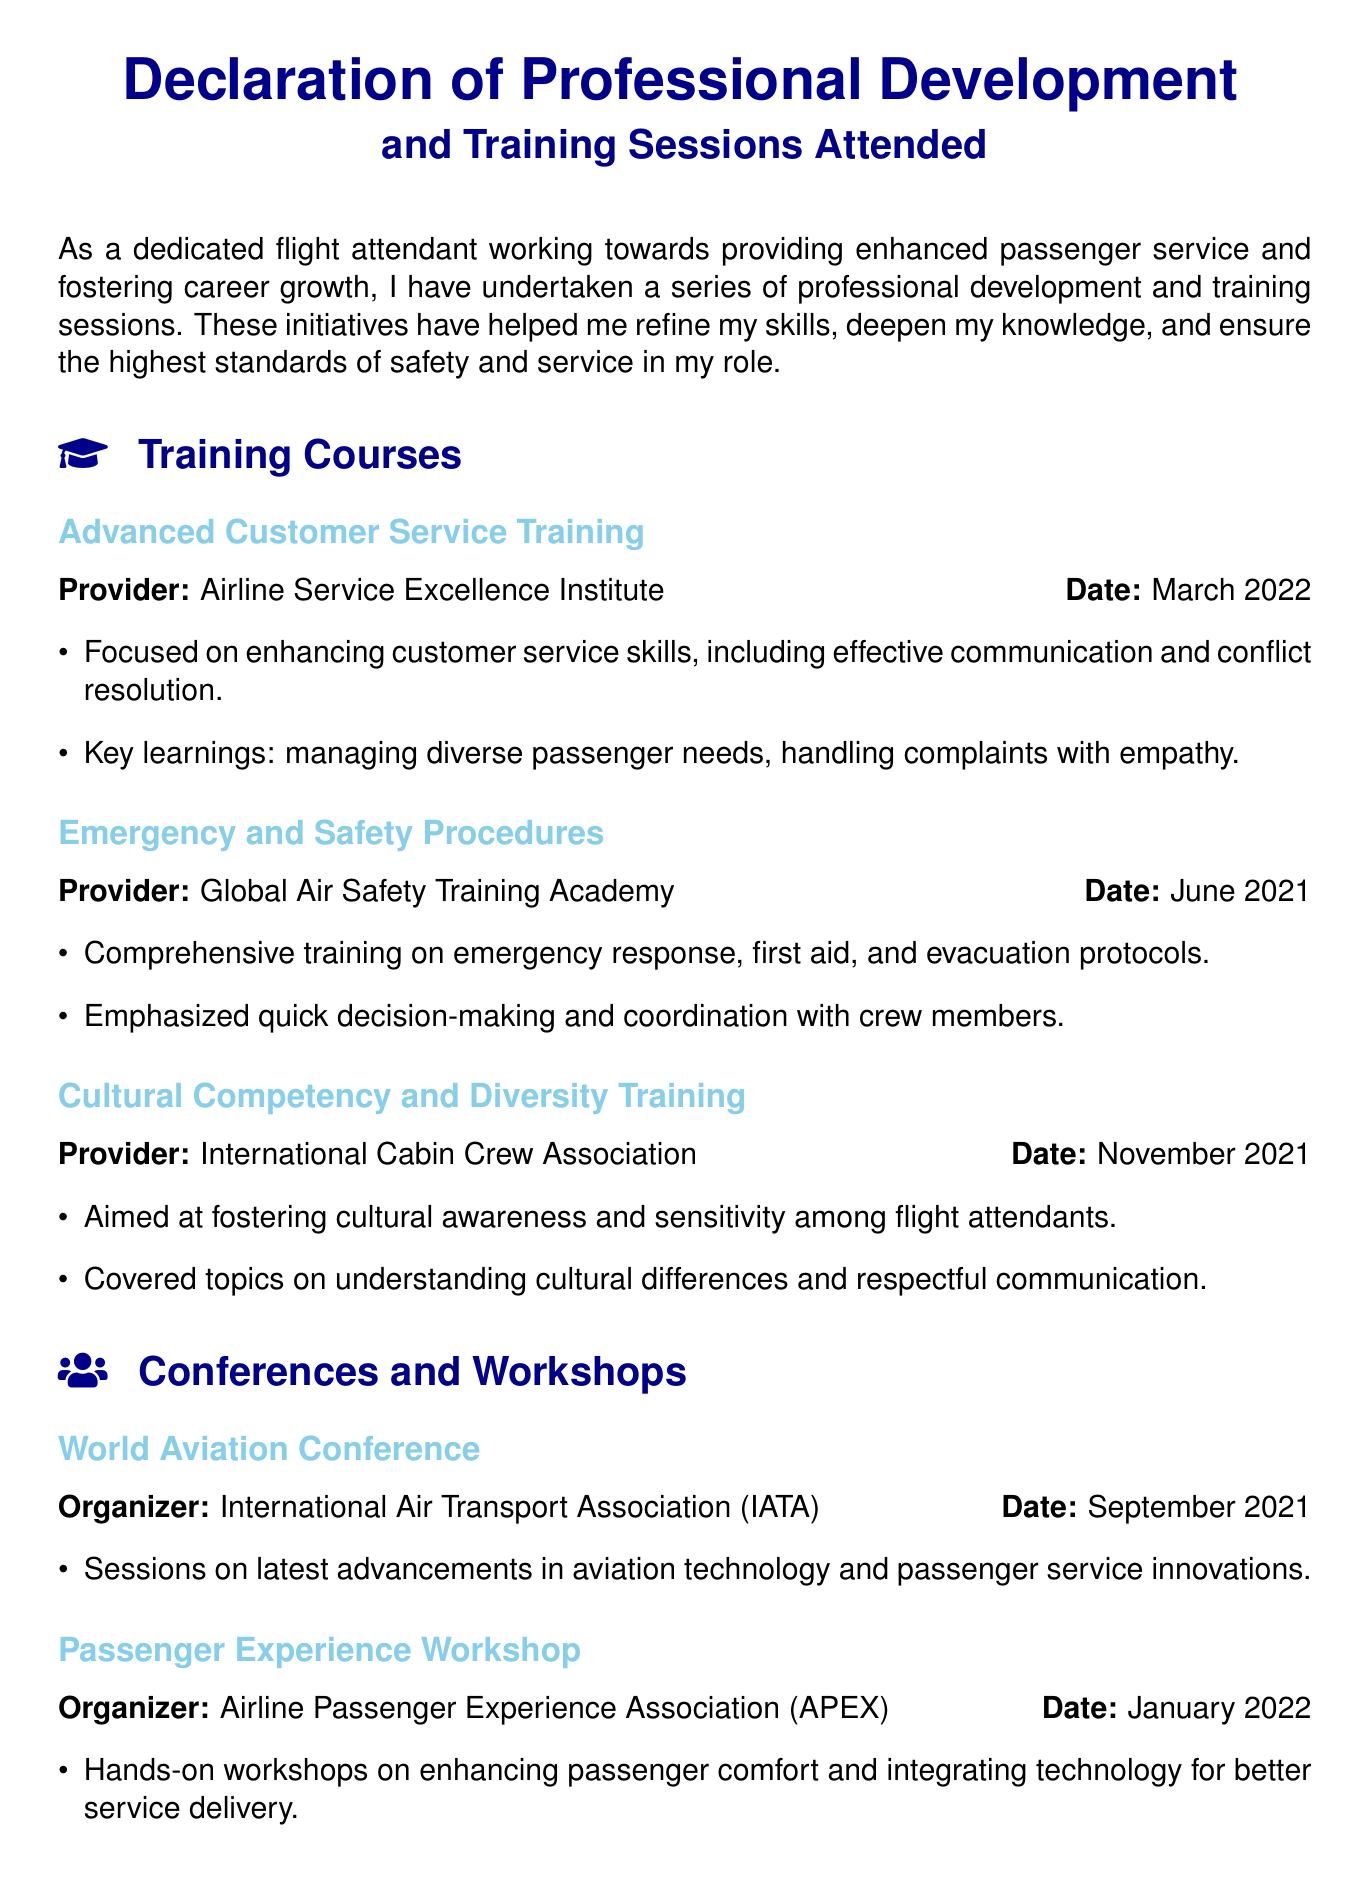What is the title of the document? The title of the document is stated prominently at the beginning, which is a Declaration of Professional Development and Training Sessions Attended.
Answer: Declaration of Professional Development and Training Sessions Attended Who provided the Advanced Customer Service Training? The provider of the Advanced Customer Service Training is mentioned in the document, identifying the organization responsible for the training.
Answer: Airline Service Excellence Institute When did the Emergency and Safety Procedures training take place? The date is clearly specified next to the training title, completing the information regarding when it was conducted.
Answer: June 2021 What was a key learning from the Cultural Competency and Diversity Training? At least one crucial takeaway from the training is highlighted under the key learnings section, indicating its importance.
Answer: Understanding cultural differences How many online courses are listed in the Additional Skills Development section? The number of courses is determined by counting the items listed under the Additional Skills Development section.
Answer: Two What was the organizer of the World Aviation Conference? The organizer's name is indicated beside the conference title, providing insight into who facilitated the event.
Answer: International Air Transport Association What type of skills did the Leadership in Aviation course focus on? The course title gives an indication of the specific leadership skills targeted for development in that domain.
Answer: Leading High-Performance Teams What month and year was the Passenger Experience Workshop held? The date of the workshop is clearly indicated alongside the title, providing specifics on when it took place.
Answer: January 2022 What does this declaration reflect? A summary statement at the end of the document provides insight into the broader significance of the training and commitment expressed within.
Answer: Commitment to professional growth 